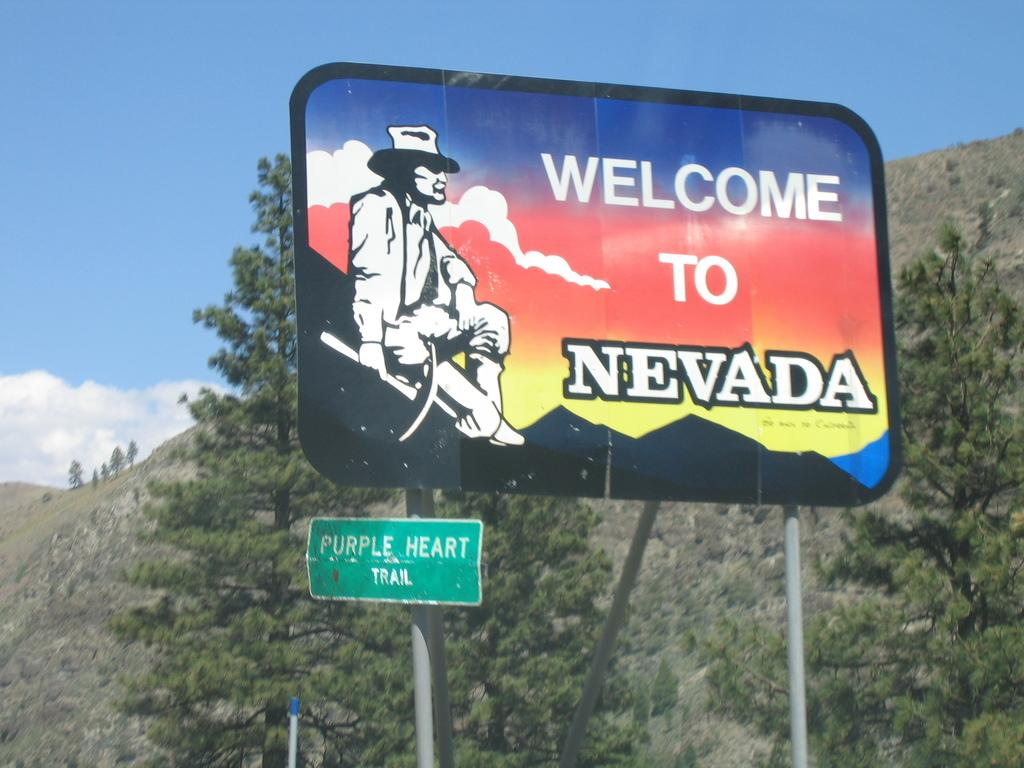<image>
Create a compact narrative representing the image presented. A large high way sign that reads welcome to nevada. 